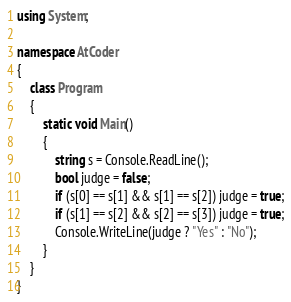<code> <loc_0><loc_0><loc_500><loc_500><_C#_>using System;

namespace AtCoder
{
    class Program
    {
        static void Main()
        {
            string s = Console.ReadLine();
            bool judge = false;
            if (s[0] == s[1] && s[1] == s[2]) judge = true;
            if (s[1] == s[2] && s[2] == s[3]) judge = true;
            Console.WriteLine(judge ? "Yes" : "No");
        }
    }
}</code> 